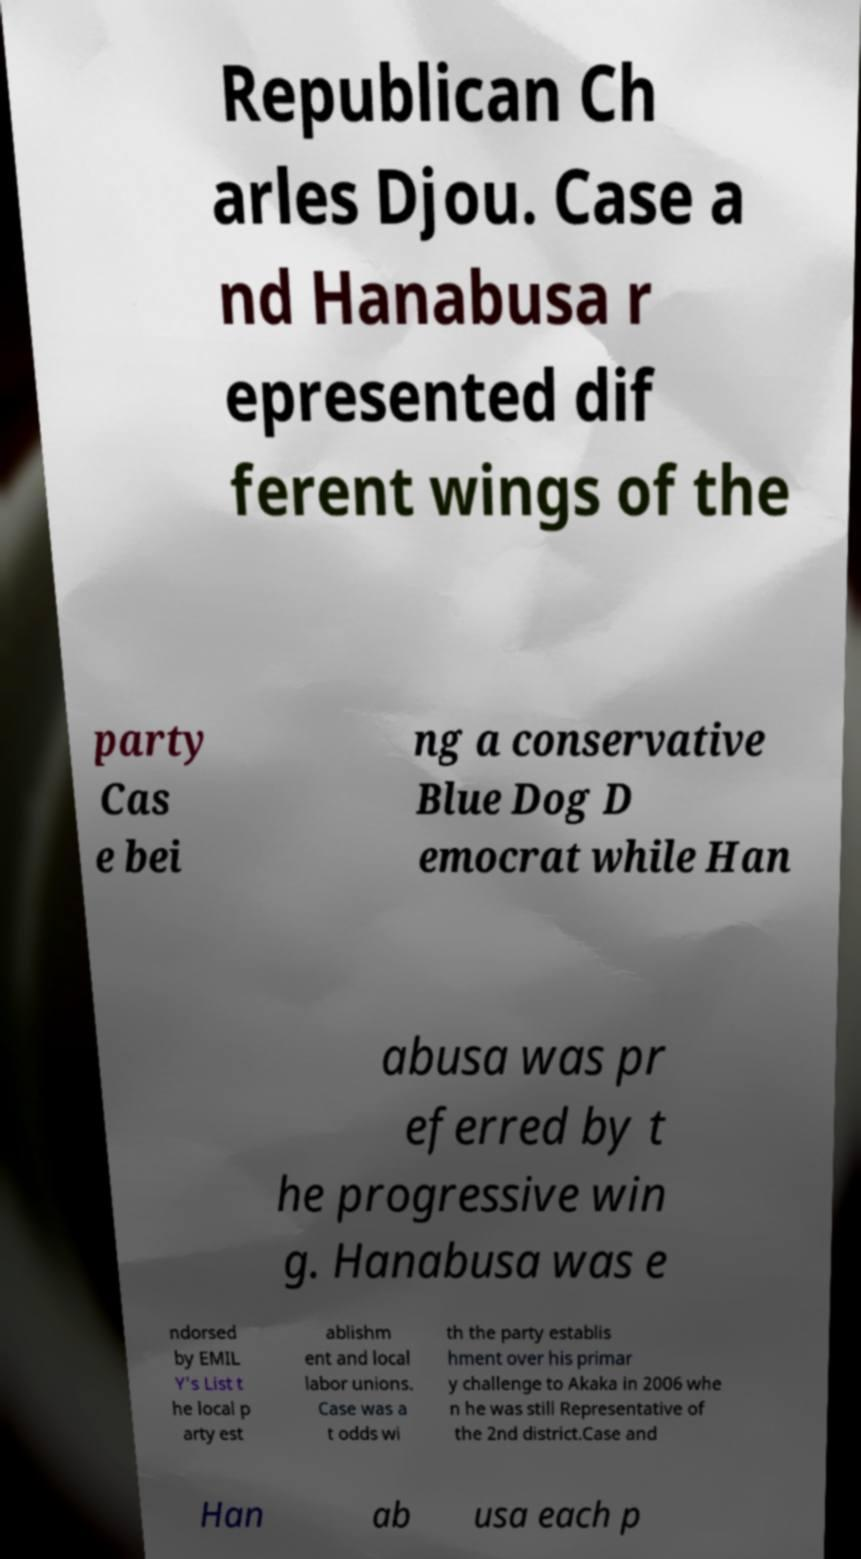There's text embedded in this image that I need extracted. Can you transcribe it verbatim? Republican Ch arles Djou. Case a nd Hanabusa r epresented dif ferent wings of the party Cas e bei ng a conservative Blue Dog D emocrat while Han abusa was pr eferred by t he progressive win g. Hanabusa was e ndorsed by EMIL Y's List t he local p arty est ablishm ent and local labor unions. Case was a t odds wi th the party establis hment over his primar y challenge to Akaka in 2006 whe n he was still Representative of the 2nd district.Case and Han ab usa each p 